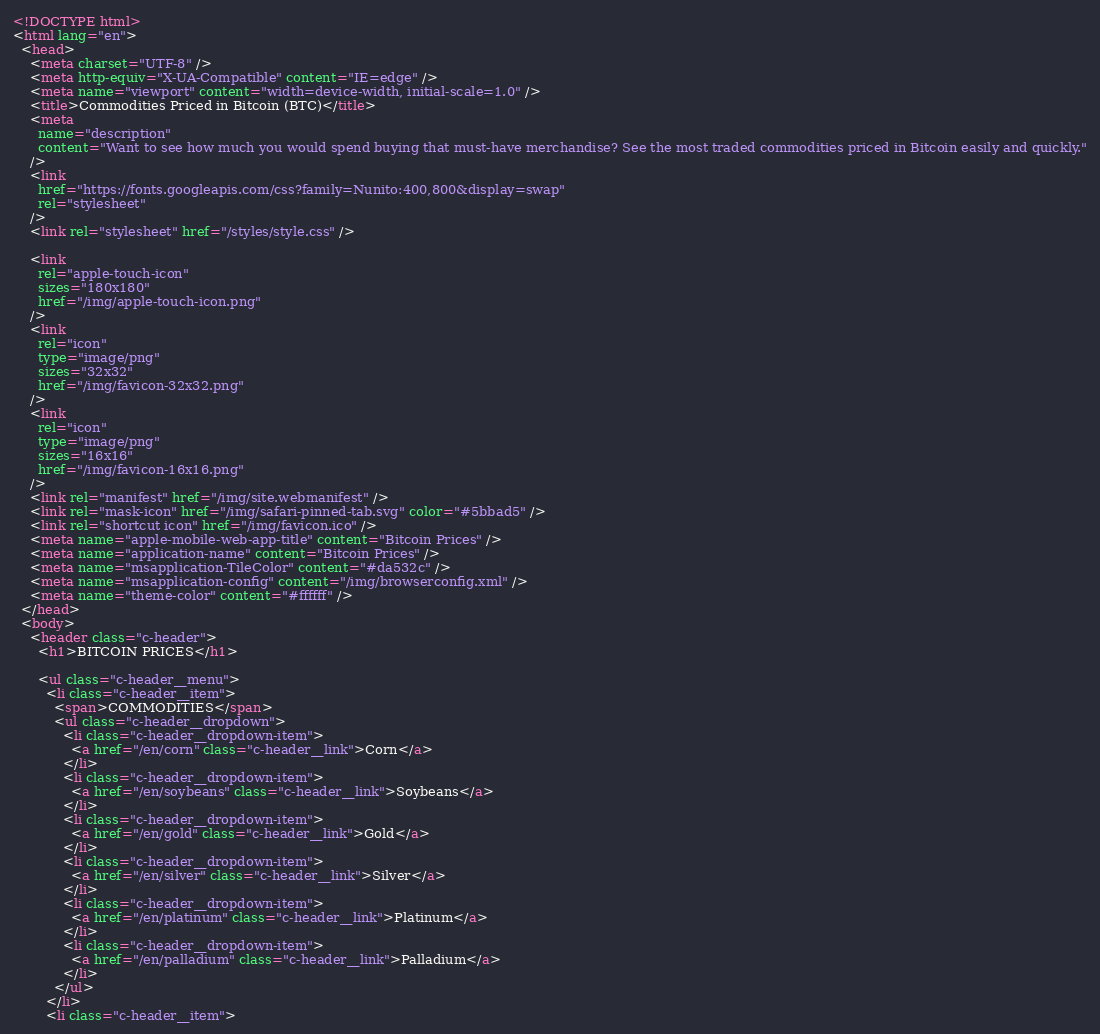Convert code to text. <code><loc_0><loc_0><loc_500><loc_500><_HTML_><!DOCTYPE html>
<html lang="en">
  <head>
    <meta charset="UTF-8" />
    <meta http-equiv="X-UA-Compatible" content="IE=edge" />
    <meta name="viewport" content="width=device-width, initial-scale=1.0" />
    <title>Commodities Priced in Bitcoin (BTC)</title>
    <meta
      name="description"
      content="Want to see how much you would spend buying that must-have merchandise? See the most traded commodities priced in Bitcoin easily and quickly."
    />
    <link
      href="https://fonts.googleapis.com/css?family=Nunito:400,800&display=swap"
      rel="stylesheet"
    />
    <link rel="stylesheet" href="/styles/style.css" />

    <link
      rel="apple-touch-icon"
      sizes="180x180"
      href="/img/apple-touch-icon.png"
    />
    <link
      rel="icon"
      type="image/png"
      sizes="32x32"
      href="/img/favicon-32x32.png"
    />
    <link
      rel="icon"
      type="image/png"
      sizes="16x16"
      href="/img/favicon-16x16.png"
    />
    <link rel="manifest" href="/img/site.webmanifest" />
    <link rel="mask-icon" href="/img/safari-pinned-tab.svg" color="#5bbad5" />
    <link rel="shortcut icon" href="/img/favicon.ico" />
    <meta name="apple-mobile-web-app-title" content="Bitcoin Prices" />
    <meta name="application-name" content="Bitcoin Prices" />
    <meta name="msapplication-TileColor" content="#da532c" />
    <meta name="msapplication-config" content="/img/browserconfig.xml" />
    <meta name="theme-color" content="#ffffff" />
  </head>
  <body>
    <header class="c-header">
      <h1>BITCOIN PRICES</h1>

      <ul class="c-header__menu">
        <li class="c-header__item">
          <span>COMMODITIES</span>
          <ul class="c-header__dropdown">
            <li class="c-header__dropdown-item">
              <a href="/en/corn" class="c-header__link">Corn</a>
            </li>
            <li class="c-header__dropdown-item">
              <a href="/en/soybeans" class="c-header__link">Soybeans</a>
            </li>
            <li class="c-header__dropdown-item">
              <a href="/en/gold" class="c-header__link">Gold</a>
            </li>
            <li class="c-header__dropdown-item">
              <a href="/en/silver" class="c-header__link">Silver</a>
            </li>
            <li class="c-header__dropdown-item">
              <a href="/en/platinum" class="c-header__link">Platinum</a>
            </li>
            <li class="c-header__dropdown-item">
              <a href="/en/palladium" class="c-header__link">Palladium</a>
            </li>
          </ul>
        </li>
        <li class="c-header__item"></code> 